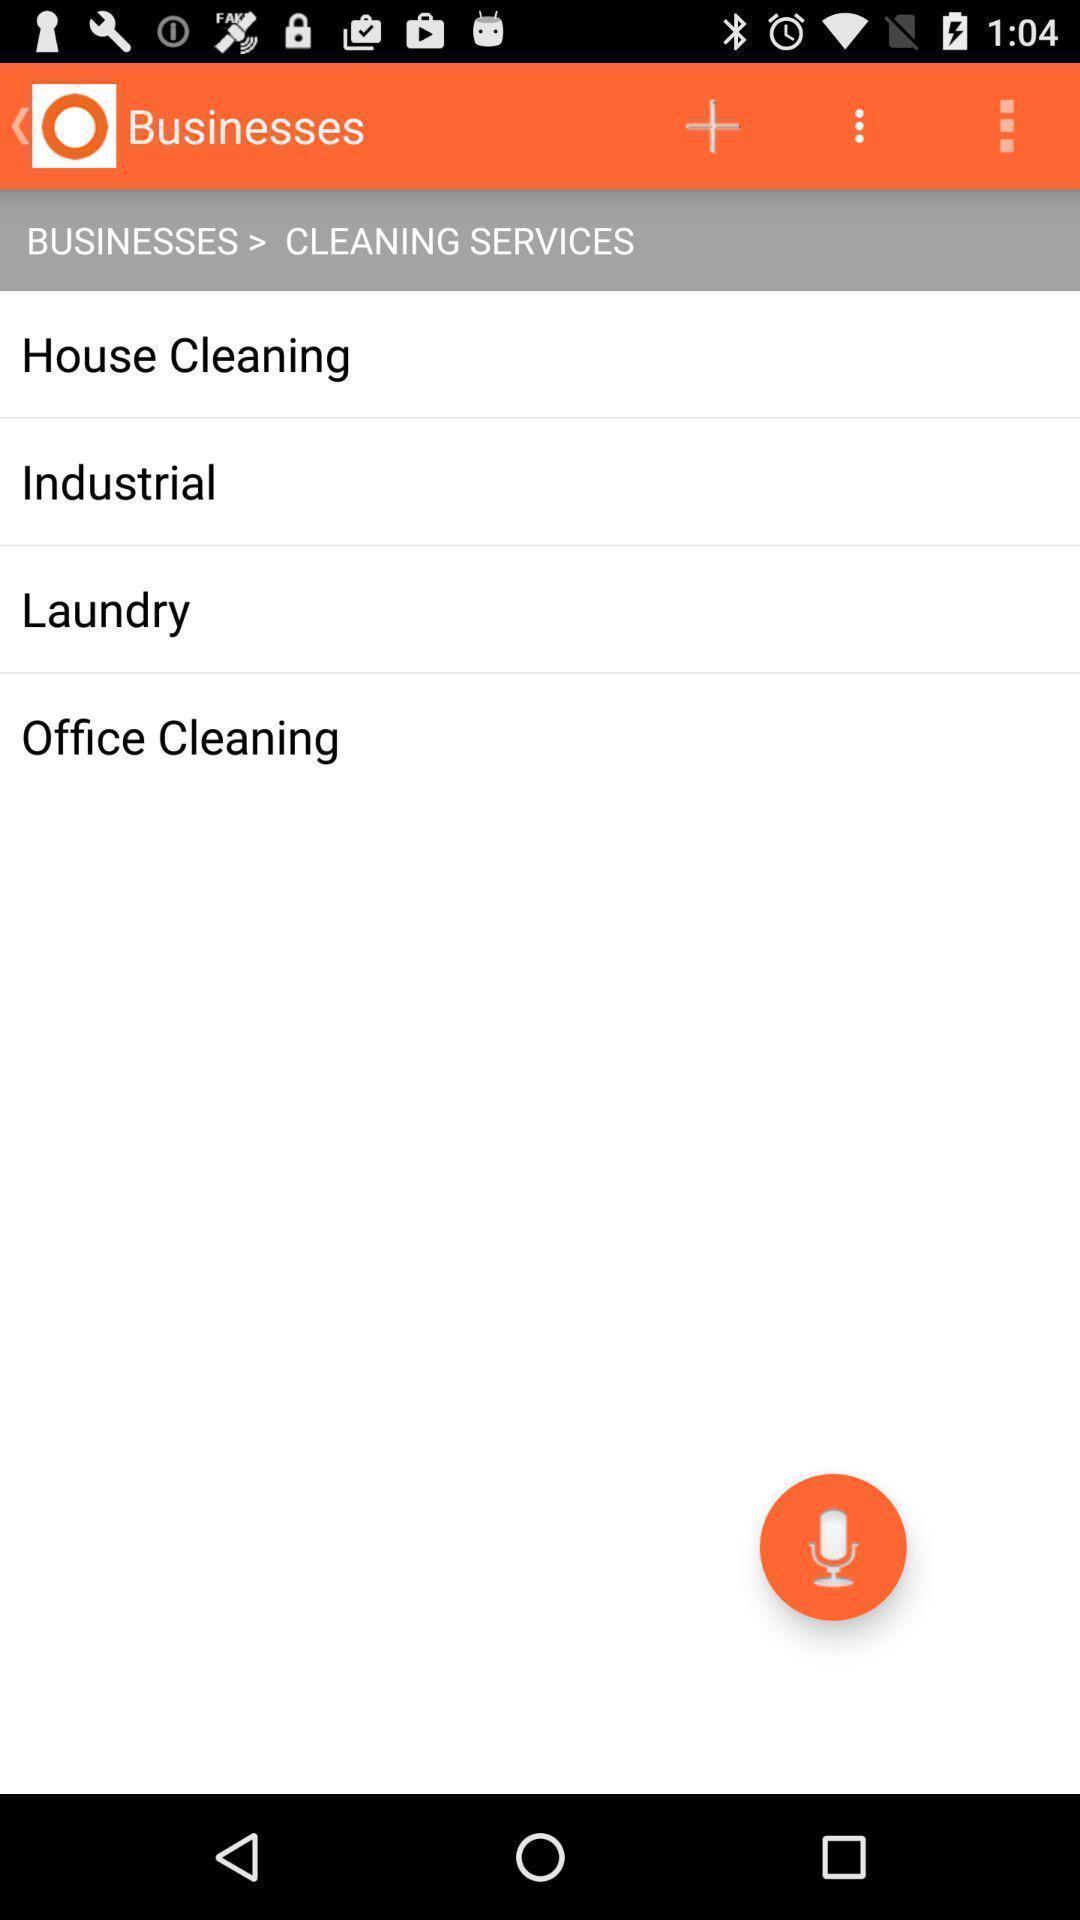Summarize the main components in this picture. Page showing business listings for cleaning services. 